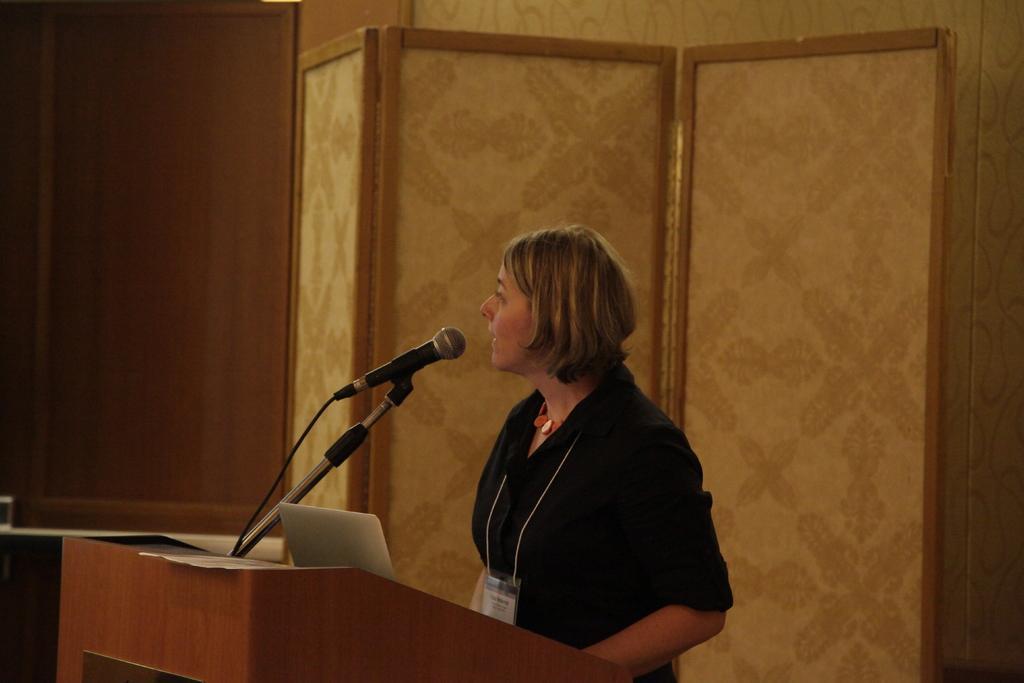Describe this image in one or two sentences. In this picture I see the podium in front on which there is a mic and I see a woman who is standing in front of the podium. In the background I see the wall. 